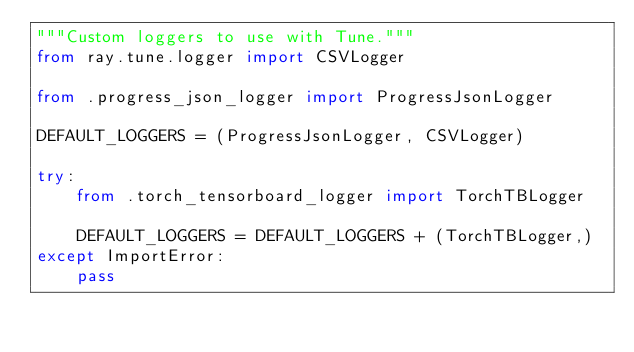<code> <loc_0><loc_0><loc_500><loc_500><_Python_>"""Custom loggers to use with Tune."""
from ray.tune.logger import CSVLogger

from .progress_json_logger import ProgressJsonLogger

DEFAULT_LOGGERS = (ProgressJsonLogger, CSVLogger)

try:
    from .torch_tensorboard_logger import TorchTBLogger

    DEFAULT_LOGGERS = DEFAULT_LOGGERS + (TorchTBLogger,)
except ImportError:
    pass
</code> 